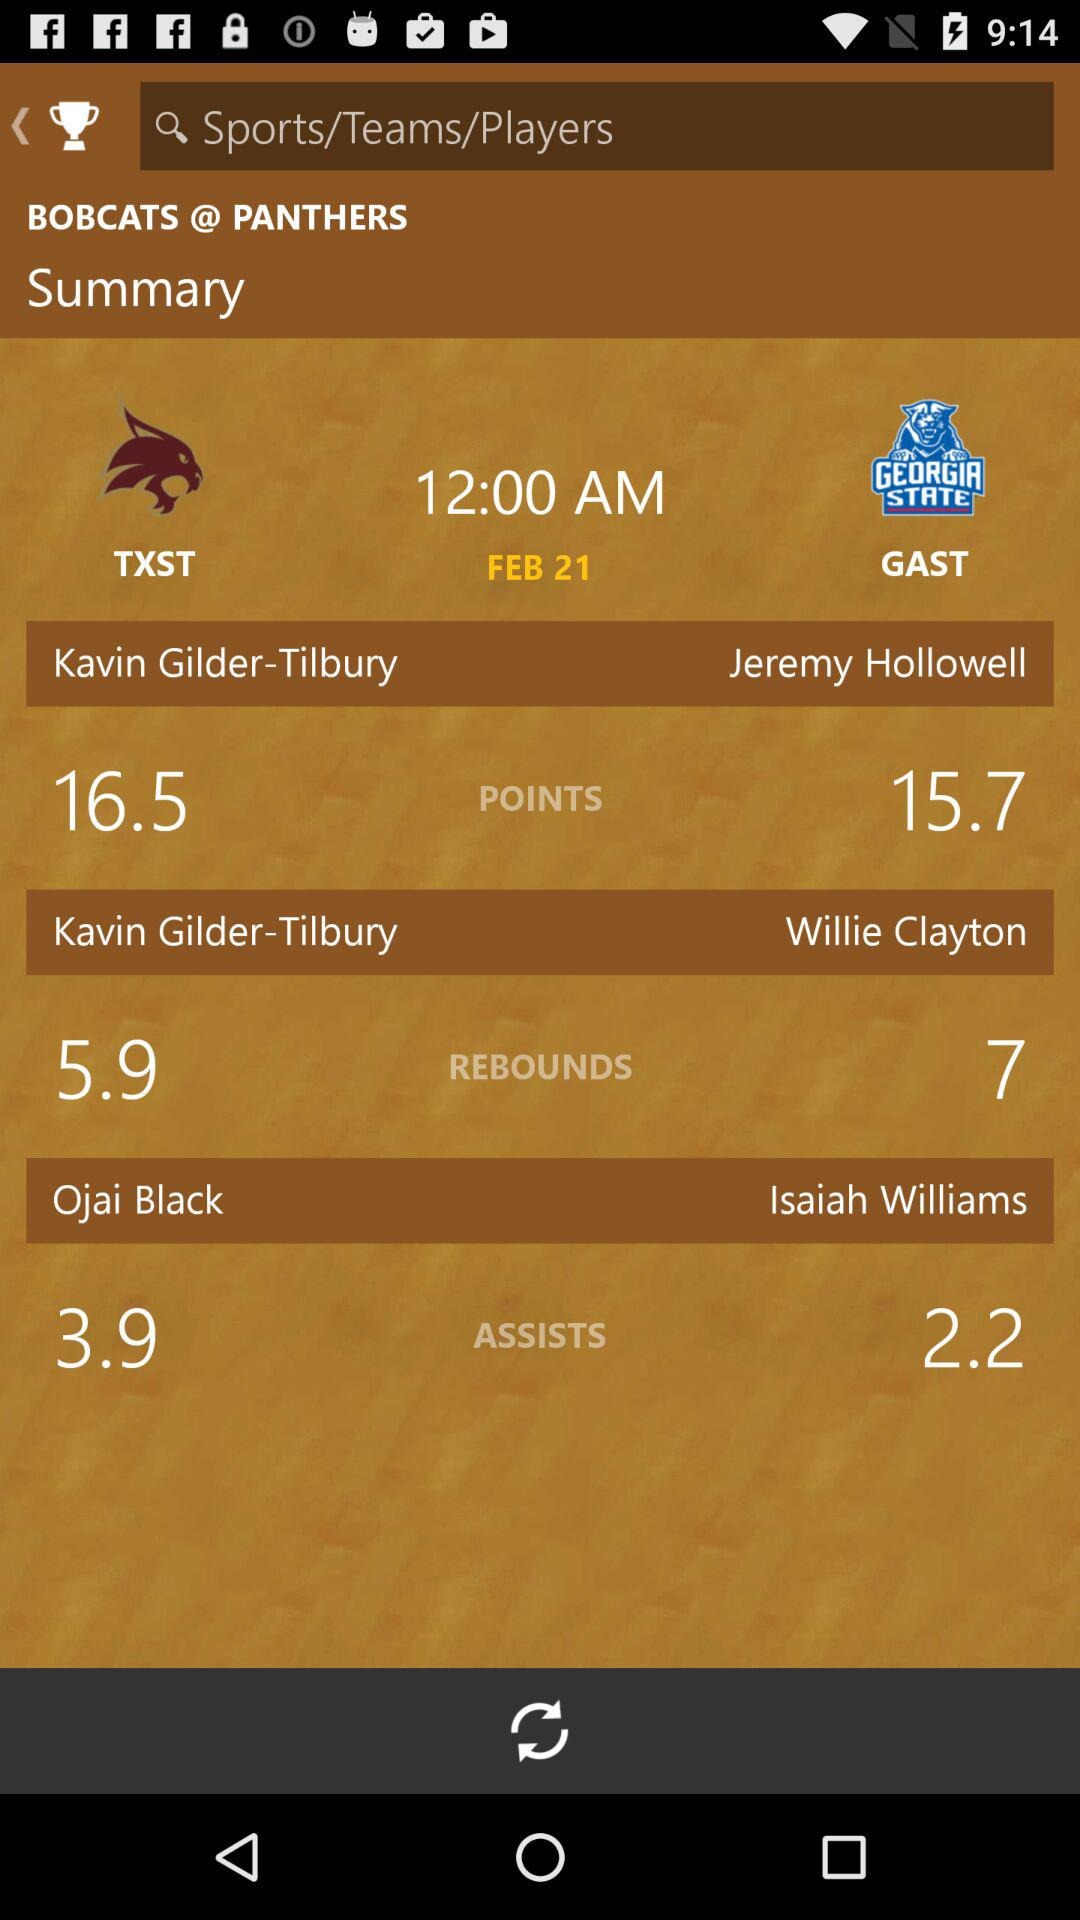What is the date of the match summary shown on the screen? The date is February 21. 